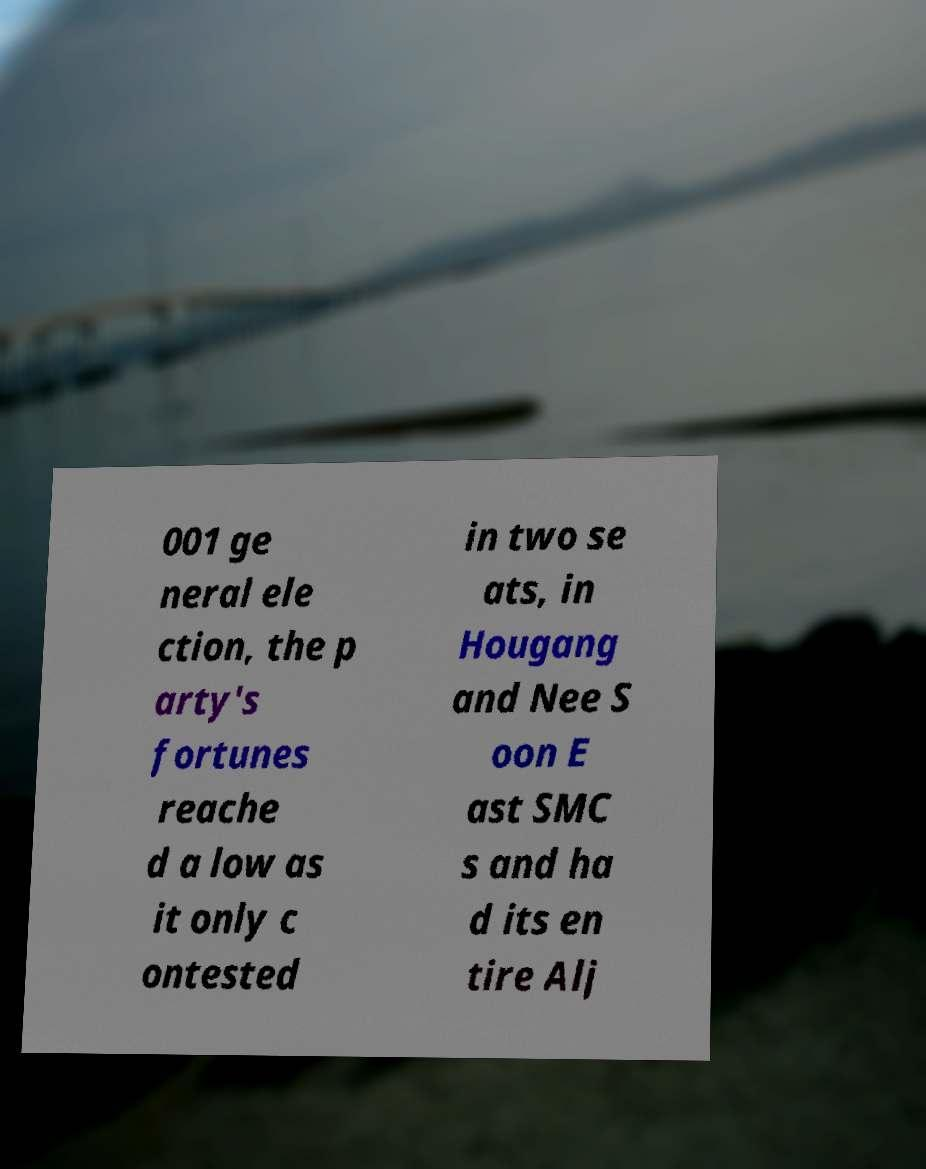Could you extract and type out the text from this image? 001 ge neral ele ction, the p arty's fortunes reache d a low as it only c ontested in two se ats, in Hougang and Nee S oon E ast SMC s and ha d its en tire Alj 